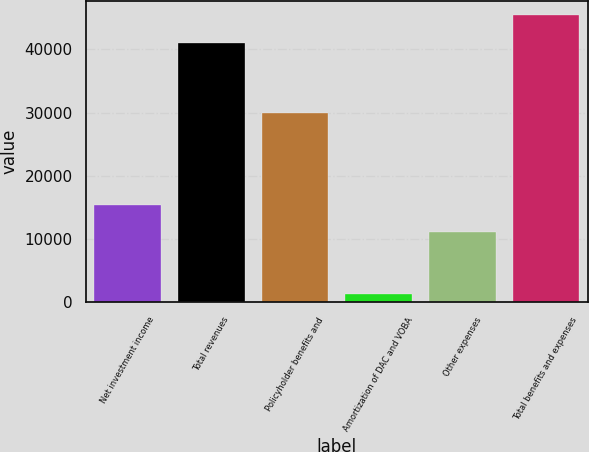Convert chart to OTSL. <chart><loc_0><loc_0><loc_500><loc_500><bar_chart><fcel>Net investment income<fcel>Total revenues<fcel>Policyholder benefits and<fcel>Amortization of DAC and VOBA<fcel>Other expenses<fcel>Total benefits and expenses<nl><fcel>15469.4<fcel>41058<fcel>29986<fcel>1307<fcel>11061<fcel>45466.4<nl></chart> 